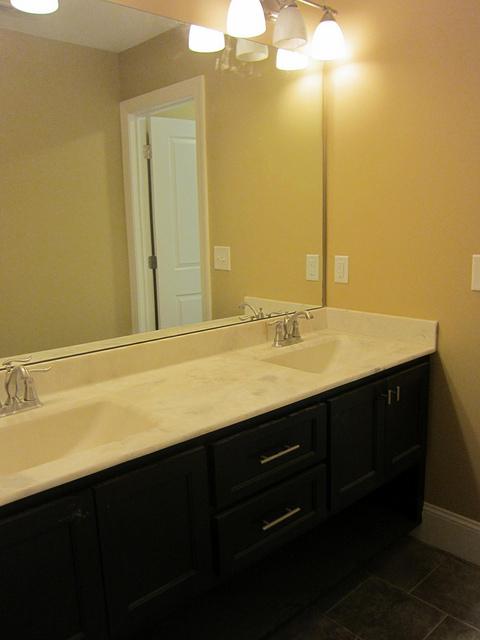Is there waste in the sinks?
Short answer required. No. How many sinks are shown?
Be succinct. 2. What is reflected in the mirror?
Concise answer only. Door. Are the lights turned on or off?
Keep it brief. On. 